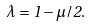Convert formula to latex. <formula><loc_0><loc_0><loc_500><loc_500>\lambda = 1 - \mu / 2 .</formula> 